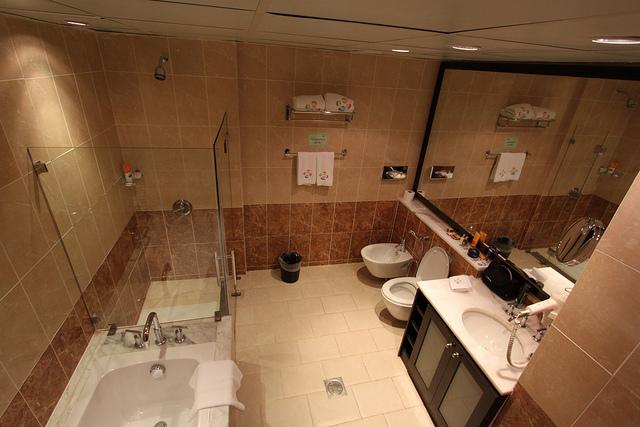Is there a reflection in the scene?
Short answer required. Yes. Where is the toilet in relation to the sink?
Quick response, please. Next to it. How many towels are there by the toilet?
Give a very brief answer. 2. 